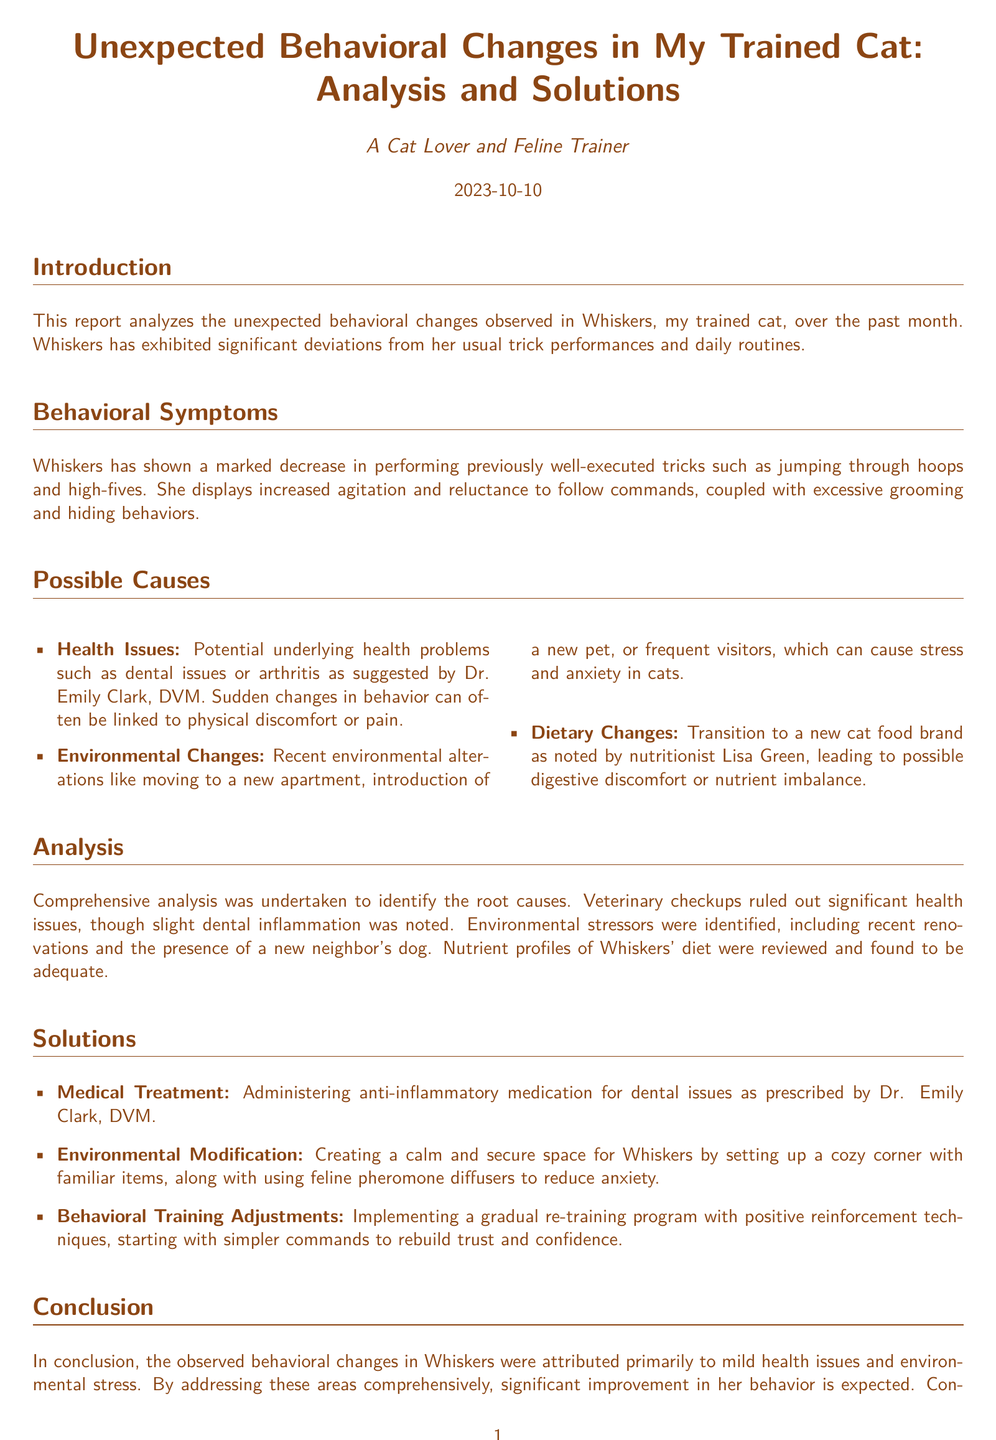What is the name of the cat mentioned in the report? The name of the cat is stated in the introduction section of the report.
Answer: Whiskers What date was the report completed? The completion date is noted at the top of the document under the title.
Answer: 2023-10-10 Who suggested health issues as a possible cause? The report attributes the suggestion of health issues to a specific veterinarian.
Answer: Dr. Emily Clark What are the three potential causes mentioned for behavioral changes? The document lists three possible causes in the 'Possible Causes' section.
Answer: Health Issues, Environmental Changes, Dietary Changes What type of medication is prescribed for Whiskers' dental issues? The medication type is detailed under the 'Solutions' section regarding medical treatment.
Answer: Anti-inflammatory What is one of the environmental modifications suggested? The suggested environmental modification is detailed in the 'Solutions' section.
Answer: Creating a calm and secure space How was Whiskers' diet evaluated? The evaluation method of Whiskers' diet is mentioned in the analysis section.
Answer: Nutrient profiles were reviewed What is the primary conclusion regarding Whiskers' behavioral changes? The conclusion summarizes the reasons behind the behavioral changes in the last section.
Answer: Mild health issues and environmental stress What type of training adjustments were suggested? The report advises on specific adjustments under the 'Solutions' section.
Answer: Gradual re-training program How was the presence of a new neighbor's dog categorized? This particular detail is categorized within environmental stressors in the analysis section.
Answer: Environmental stressor 